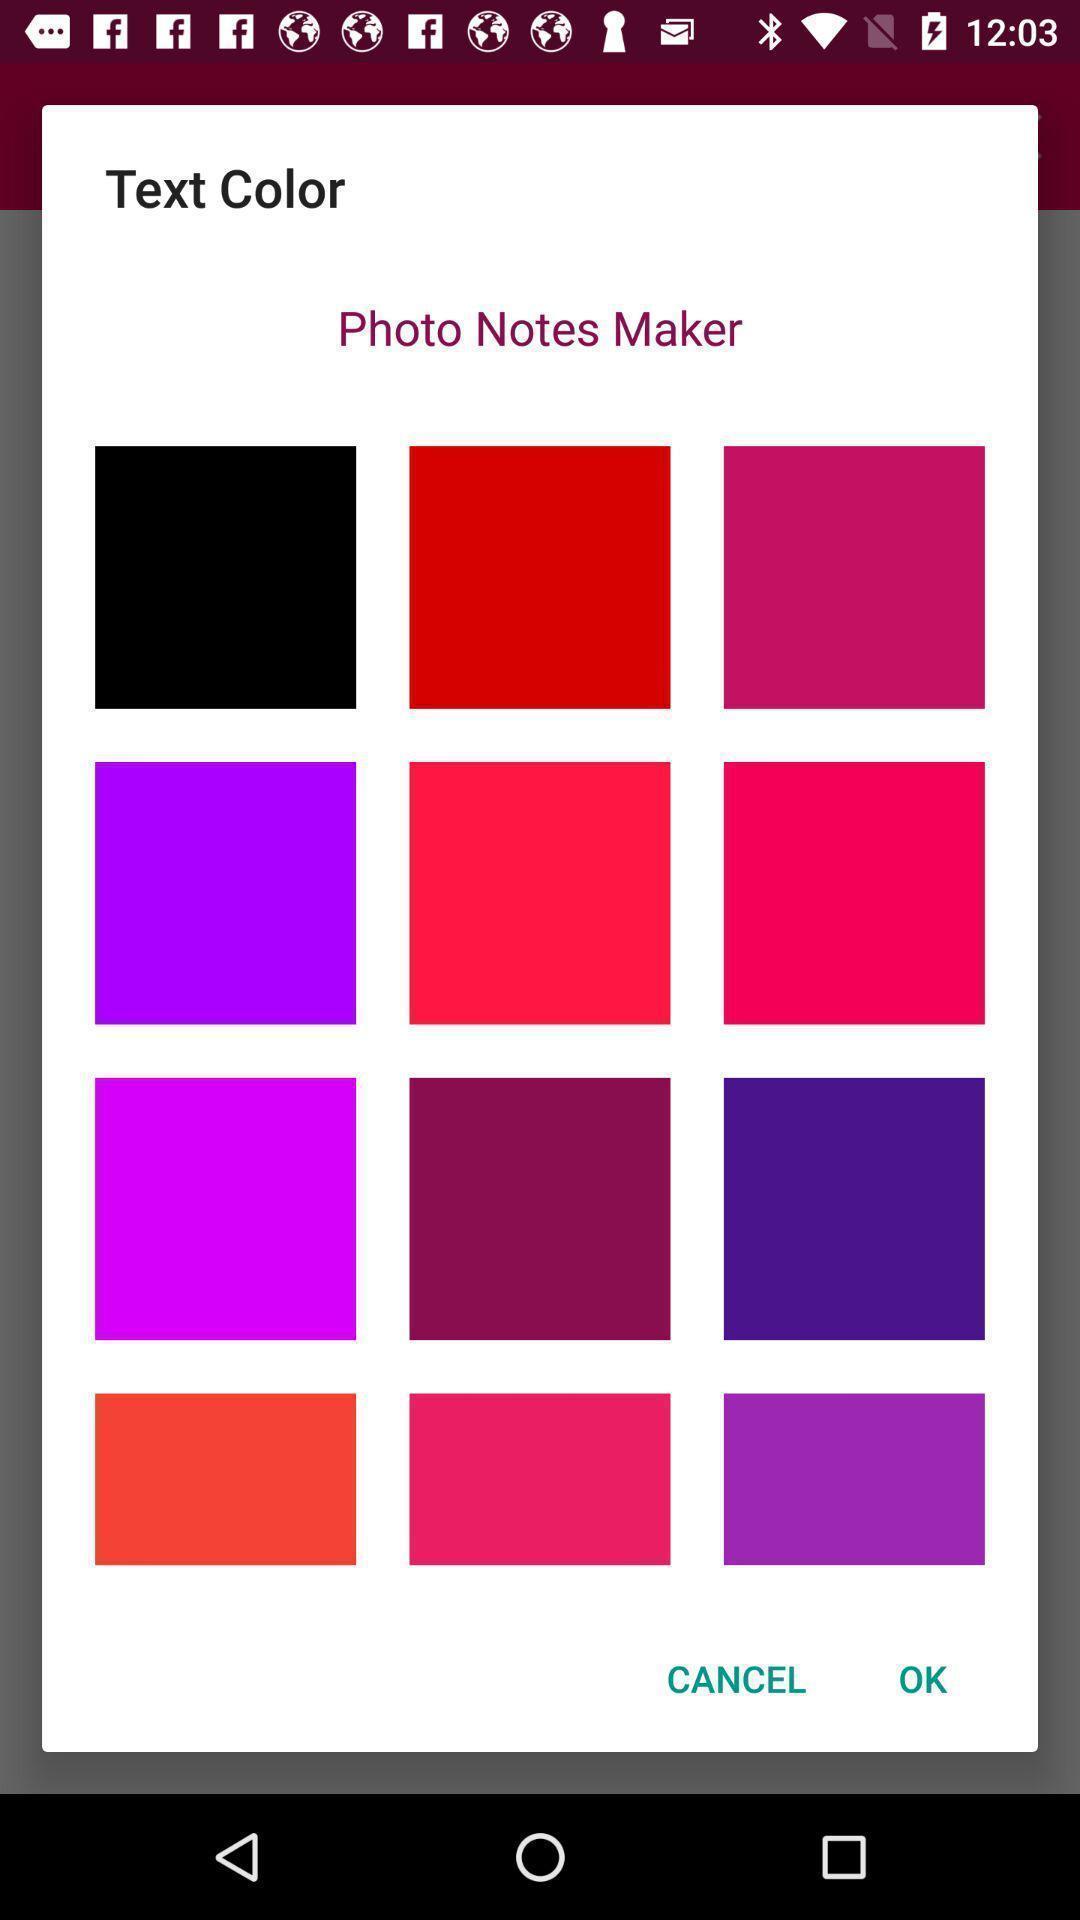Provide a detailed account of this screenshot. Pop-up to select color in the list. 